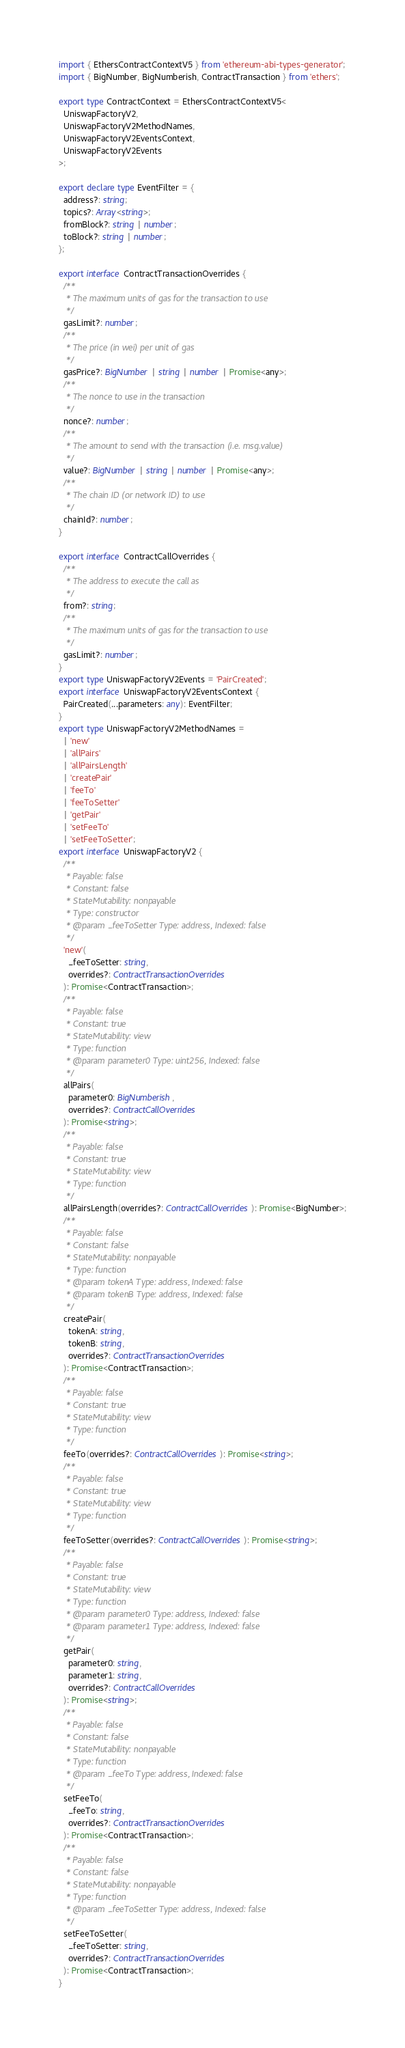<code> <loc_0><loc_0><loc_500><loc_500><_TypeScript_>import { EthersContractContextV5 } from 'ethereum-abi-types-generator';
import { BigNumber, BigNumberish, ContractTransaction } from 'ethers';

export type ContractContext = EthersContractContextV5<
  UniswapFactoryV2,
  UniswapFactoryV2MethodNames,
  UniswapFactoryV2EventsContext,
  UniswapFactoryV2Events
>;

export declare type EventFilter = {
  address?: string;
  topics?: Array<string>;
  fromBlock?: string | number;
  toBlock?: string | number;
};

export interface ContractTransactionOverrides {
  /**
   * The maximum units of gas for the transaction to use
   */
  gasLimit?: number;
  /**
   * The price (in wei) per unit of gas
   */
  gasPrice?: BigNumber | string | number | Promise<any>;
  /**
   * The nonce to use in the transaction
   */
  nonce?: number;
  /**
   * The amount to send with the transaction (i.e. msg.value)
   */
  value?: BigNumber | string | number | Promise<any>;
  /**
   * The chain ID (or network ID) to use
   */
  chainId?: number;
}

export interface ContractCallOverrides {
  /**
   * The address to execute the call as
   */
  from?: string;
  /**
   * The maximum units of gas for the transaction to use
   */
  gasLimit?: number;
}
export type UniswapFactoryV2Events = 'PairCreated';
export interface UniswapFactoryV2EventsContext {
  PairCreated(...parameters: any): EventFilter;
}
export type UniswapFactoryV2MethodNames =
  | 'new'
  | 'allPairs'
  | 'allPairsLength'
  | 'createPair'
  | 'feeTo'
  | 'feeToSetter'
  | 'getPair'
  | 'setFeeTo'
  | 'setFeeToSetter';
export interface UniswapFactoryV2 {
  /**
   * Payable: false
   * Constant: false
   * StateMutability: nonpayable
   * Type: constructor
   * @param _feeToSetter Type: address, Indexed: false
   */
  'new'(
    _feeToSetter: string,
    overrides?: ContractTransactionOverrides
  ): Promise<ContractTransaction>;
  /**
   * Payable: false
   * Constant: true
   * StateMutability: view
   * Type: function
   * @param parameter0 Type: uint256, Indexed: false
   */
  allPairs(
    parameter0: BigNumberish,
    overrides?: ContractCallOverrides
  ): Promise<string>;
  /**
   * Payable: false
   * Constant: true
   * StateMutability: view
   * Type: function
   */
  allPairsLength(overrides?: ContractCallOverrides): Promise<BigNumber>;
  /**
   * Payable: false
   * Constant: false
   * StateMutability: nonpayable
   * Type: function
   * @param tokenA Type: address, Indexed: false
   * @param tokenB Type: address, Indexed: false
   */
  createPair(
    tokenA: string,
    tokenB: string,
    overrides?: ContractTransactionOverrides
  ): Promise<ContractTransaction>;
  /**
   * Payable: false
   * Constant: true
   * StateMutability: view
   * Type: function
   */
  feeTo(overrides?: ContractCallOverrides): Promise<string>;
  /**
   * Payable: false
   * Constant: true
   * StateMutability: view
   * Type: function
   */
  feeToSetter(overrides?: ContractCallOverrides): Promise<string>;
  /**
   * Payable: false
   * Constant: true
   * StateMutability: view
   * Type: function
   * @param parameter0 Type: address, Indexed: false
   * @param parameter1 Type: address, Indexed: false
   */
  getPair(
    parameter0: string,
    parameter1: string,
    overrides?: ContractCallOverrides
  ): Promise<string>;
  /**
   * Payable: false
   * Constant: false
   * StateMutability: nonpayable
   * Type: function
   * @param _feeTo Type: address, Indexed: false
   */
  setFeeTo(
    _feeTo: string,
    overrides?: ContractTransactionOverrides
  ): Promise<ContractTransaction>;
  /**
   * Payable: false
   * Constant: false
   * StateMutability: nonpayable
   * Type: function
   * @param _feeToSetter Type: address, Indexed: false
   */
  setFeeToSetter(
    _feeToSetter: string,
    overrides?: ContractTransactionOverrides
  ): Promise<ContractTransaction>;
}
</code> 